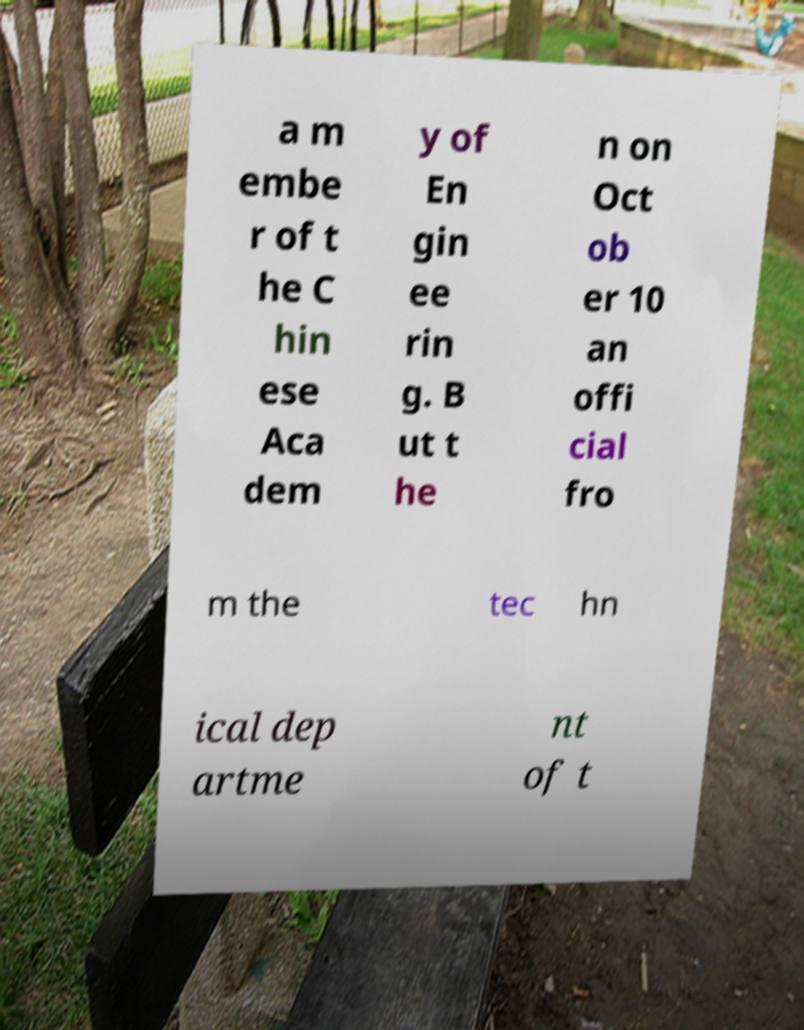Could you assist in decoding the text presented in this image and type it out clearly? a m embe r of t he C hin ese Aca dem y of En gin ee rin g. B ut t he n on Oct ob er 10 an offi cial fro m the tec hn ical dep artme nt of t 